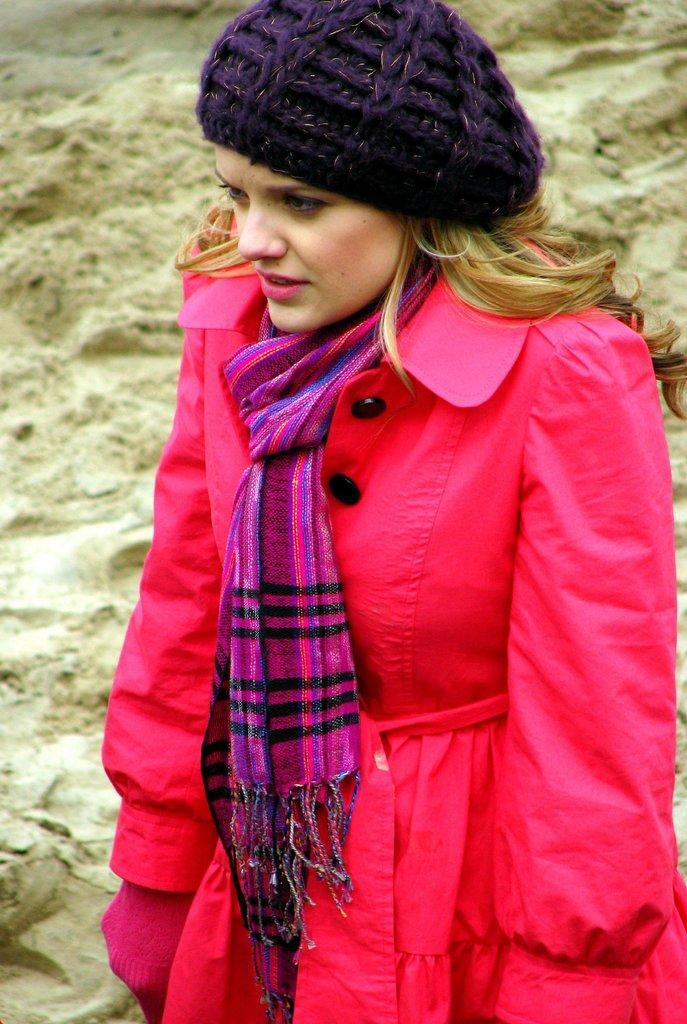Describe this image in one or two sentences. The woman in the middle of the picture wearing a pink jacket is standing. She's even wearing a pink scarf and a blue cap. Behind her, we see sand. 